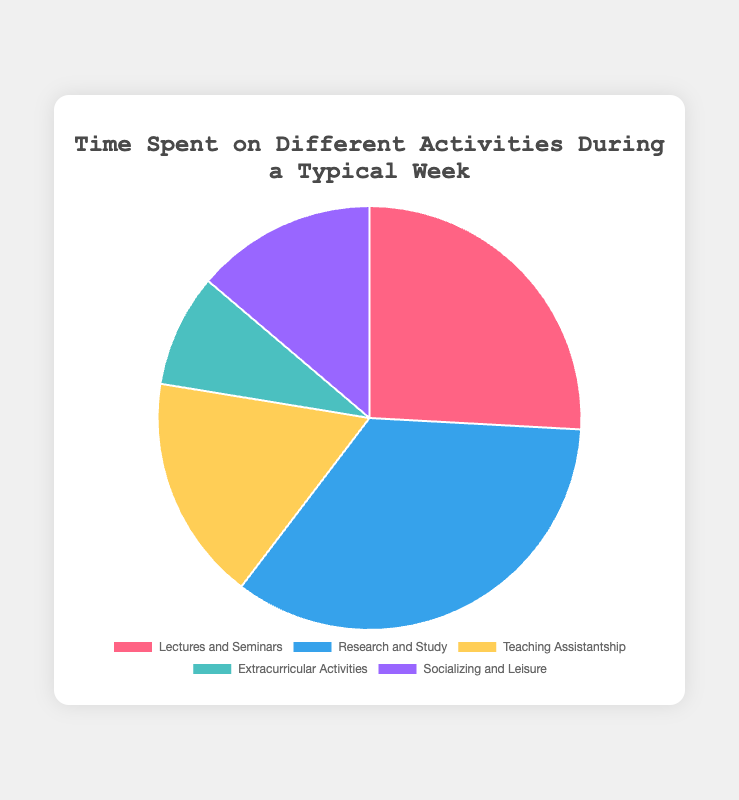Which activity occupies the most time during a typical week? "Research and Study" occupies the most time at 20 hours per week, which is the largest segment in the pie chart.
Answer: Research and Study How many hours do Lectures and Seminars and Teaching Assistantship together account for? Add the hours for "Lectures and Seminars" (15 hours) and "Teaching Assistantship" (10 hours): 15 + 10 = 25 hours.
Answer: 25 Which activity takes less time than Socializing and Leisure? "Extracurricular Activities" takes less time than "Socializing and Leisure" since it only accounts for 5 hours compared to 8 hours.
Answer: Extracurricular Activities How does the time spent on Socializing and Leisure compare to the time spent on Teaching Assistantship? "Socializing and Leisure" has 8 hours, which is 2 hours less than "Teaching Assistantship," which has 10 hours.
Answer: 2 hours less What's the total time spent on all activities? Sum all the hours spent on each activity: 15 + 20 + 10 + 5 + 8 = 58 hours.
Answer: 58 What is the average number of hours spent per activity? Divide the total time spent (58 hours) by the number of activities (5): 58 / 5 = 11.6 hours.
Answer: 11.6 Which activity is represented by the yellow segment? The yellow segment represents "Teaching Assistantship" as indicated by the consistent color scheme.
Answer: Teaching Assistantship Is the time spent on Extracurricular Activities more or less than half the time spent on Research and Study? "Extracurricular Activities" is 5 hours while half of "Research and Study" would be 20 / 2 = 10 hours. 5 is less than 10.
Answer: Less How much more time is spent on Research and Study compared to Lectures and Seminars? "Research and Study" has 20 hours, and "Lectures and Seminars" has 15 hours. The difference is 20 - 15 = 5 hours more.
Answer: 5 hours What percentage of the total time is spent on Teaching Assistantship? Divide the hours for "Teaching Assistantship" (10 hours) by the total hours (58) and multiply by 100 to get the percentage: (10 / 58) * 100 ≈ 17.24%.
Answer: 17.24% 